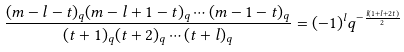<formula> <loc_0><loc_0><loc_500><loc_500>\frac { ( m - l - t ) _ { q } ( m - l + 1 - t ) _ { q } \cdots ( m - 1 - t ) _ { q } } { ( t + 1 ) _ { q } ( t + 2 ) _ { q } \cdots ( t + l ) _ { q } } = ( - 1 ) ^ { l } q ^ { - \frac { l ( 1 + l + 2 t ) } { 2 } }</formula> 